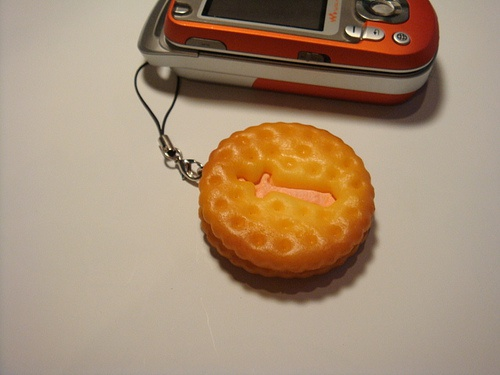Describe the objects in this image and their specific colors. I can see a cell phone in darkgray, maroon, black, and gray tones in this image. 